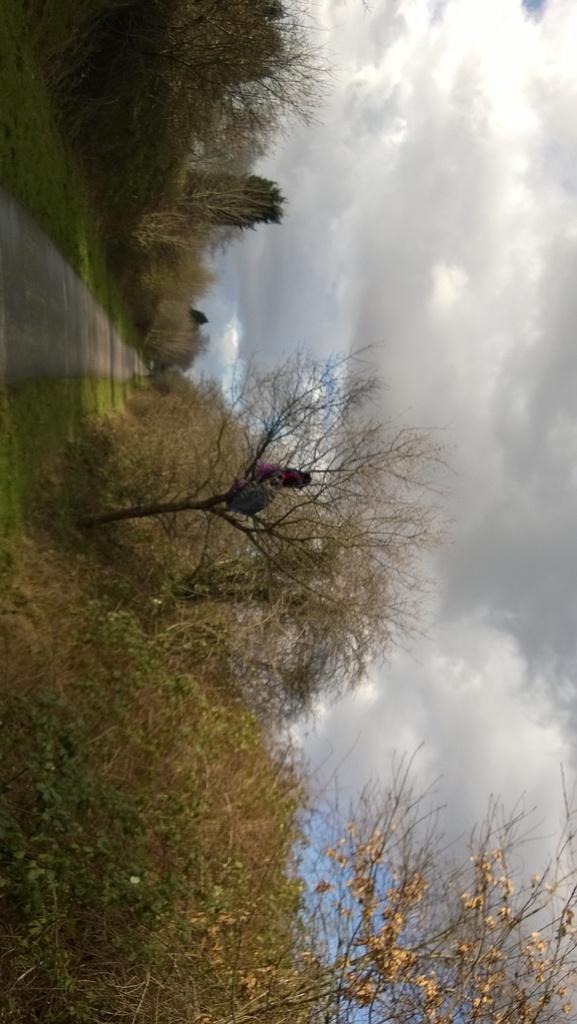In one or two sentences, can you explain what this image depicts? In this picture I can see trees and sky. I can also see a road. 